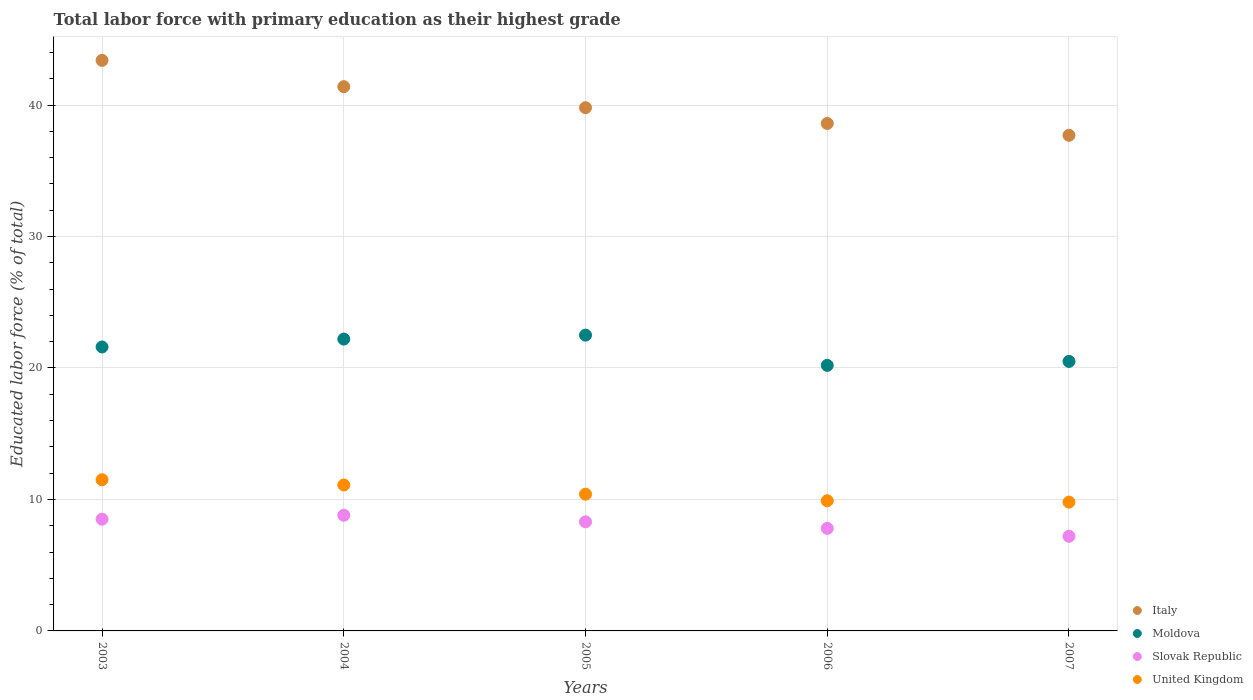How many different coloured dotlines are there?
Give a very brief answer. 4. What is the percentage of total labor force with primary education in Slovak Republic in 2004?
Make the answer very short. 8.8. Across all years, what is the maximum percentage of total labor force with primary education in United Kingdom?
Keep it short and to the point. 11.5. Across all years, what is the minimum percentage of total labor force with primary education in Slovak Republic?
Provide a short and direct response. 7.2. In which year was the percentage of total labor force with primary education in Slovak Republic maximum?
Your answer should be very brief. 2004. In which year was the percentage of total labor force with primary education in Slovak Republic minimum?
Make the answer very short. 2007. What is the total percentage of total labor force with primary education in United Kingdom in the graph?
Make the answer very short. 52.7. What is the difference between the percentage of total labor force with primary education in United Kingdom in 2006 and that in 2007?
Give a very brief answer. 0.1. What is the difference between the percentage of total labor force with primary education in Italy in 2006 and the percentage of total labor force with primary education in Slovak Republic in 2004?
Offer a terse response. 29.8. What is the average percentage of total labor force with primary education in Moldova per year?
Your response must be concise. 21.4. In the year 2005, what is the difference between the percentage of total labor force with primary education in Moldova and percentage of total labor force with primary education in United Kingdom?
Keep it short and to the point. 12.1. In how many years, is the percentage of total labor force with primary education in Italy greater than 2 %?
Provide a succinct answer. 5. What is the ratio of the percentage of total labor force with primary education in Moldova in 2004 to that in 2005?
Give a very brief answer. 0.99. Is the percentage of total labor force with primary education in Slovak Republic in 2003 less than that in 2006?
Your response must be concise. No. What is the difference between the highest and the second highest percentage of total labor force with primary education in United Kingdom?
Your response must be concise. 0.4. What is the difference between the highest and the lowest percentage of total labor force with primary education in Italy?
Provide a succinct answer. 5.7. Is it the case that in every year, the sum of the percentage of total labor force with primary education in Moldova and percentage of total labor force with primary education in United Kingdom  is greater than the sum of percentage of total labor force with primary education in Slovak Republic and percentage of total labor force with primary education in Italy?
Your response must be concise. Yes. Is it the case that in every year, the sum of the percentage of total labor force with primary education in Moldova and percentage of total labor force with primary education in Slovak Republic  is greater than the percentage of total labor force with primary education in Italy?
Keep it short and to the point. No. Does the percentage of total labor force with primary education in Moldova monotonically increase over the years?
Give a very brief answer. No. Is the percentage of total labor force with primary education in Slovak Republic strictly less than the percentage of total labor force with primary education in Italy over the years?
Provide a succinct answer. Yes. How many dotlines are there?
Your response must be concise. 4. What is the difference between two consecutive major ticks on the Y-axis?
Offer a very short reply. 10. Are the values on the major ticks of Y-axis written in scientific E-notation?
Your response must be concise. No. Does the graph contain any zero values?
Give a very brief answer. No. Does the graph contain grids?
Provide a short and direct response. Yes. How are the legend labels stacked?
Keep it short and to the point. Vertical. What is the title of the graph?
Your answer should be very brief. Total labor force with primary education as their highest grade. What is the label or title of the X-axis?
Your response must be concise. Years. What is the label or title of the Y-axis?
Keep it short and to the point. Educated labor force (% of total). What is the Educated labor force (% of total) in Italy in 2003?
Keep it short and to the point. 43.4. What is the Educated labor force (% of total) in Moldova in 2003?
Your answer should be very brief. 21.6. What is the Educated labor force (% of total) in Slovak Republic in 2003?
Your answer should be very brief. 8.5. What is the Educated labor force (% of total) in Italy in 2004?
Your response must be concise. 41.4. What is the Educated labor force (% of total) of Moldova in 2004?
Offer a very short reply. 22.2. What is the Educated labor force (% of total) in Slovak Republic in 2004?
Ensure brevity in your answer.  8.8. What is the Educated labor force (% of total) of United Kingdom in 2004?
Provide a succinct answer. 11.1. What is the Educated labor force (% of total) of Italy in 2005?
Provide a short and direct response. 39.8. What is the Educated labor force (% of total) of Moldova in 2005?
Offer a terse response. 22.5. What is the Educated labor force (% of total) in Slovak Republic in 2005?
Ensure brevity in your answer.  8.3. What is the Educated labor force (% of total) of United Kingdom in 2005?
Your answer should be very brief. 10.4. What is the Educated labor force (% of total) of Italy in 2006?
Your answer should be very brief. 38.6. What is the Educated labor force (% of total) of Moldova in 2006?
Your answer should be very brief. 20.2. What is the Educated labor force (% of total) of Slovak Republic in 2006?
Give a very brief answer. 7.8. What is the Educated labor force (% of total) of United Kingdom in 2006?
Make the answer very short. 9.9. What is the Educated labor force (% of total) in Italy in 2007?
Keep it short and to the point. 37.7. What is the Educated labor force (% of total) in Moldova in 2007?
Provide a succinct answer. 20.5. What is the Educated labor force (% of total) of Slovak Republic in 2007?
Your answer should be compact. 7.2. What is the Educated labor force (% of total) in United Kingdom in 2007?
Provide a short and direct response. 9.8. Across all years, what is the maximum Educated labor force (% of total) in Italy?
Provide a short and direct response. 43.4. Across all years, what is the maximum Educated labor force (% of total) in Moldova?
Ensure brevity in your answer.  22.5. Across all years, what is the maximum Educated labor force (% of total) of Slovak Republic?
Give a very brief answer. 8.8. Across all years, what is the maximum Educated labor force (% of total) in United Kingdom?
Ensure brevity in your answer.  11.5. Across all years, what is the minimum Educated labor force (% of total) of Italy?
Your answer should be compact. 37.7. Across all years, what is the minimum Educated labor force (% of total) of Moldova?
Provide a succinct answer. 20.2. Across all years, what is the minimum Educated labor force (% of total) of Slovak Republic?
Ensure brevity in your answer.  7.2. Across all years, what is the minimum Educated labor force (% of total) of United Kingdom?
Make the answer very short. 9.8. What is the total Educated labor force (% of total) in Italy in the graph?
Offer a terse response. 200.9. What is the total Educated labor force (% of total) of Moldova in the graph?
Keep it short and to the point. 107. What is the total Educated labor force (% of total) in Slovak Republic in the graph?
Provide a succinct answer. 40.6. What is the total Educated labor force (% of total) of United Kingdom in the graph?
Your answer should be compact. 52.7. What is the difference between the Educated labor force (% of total) of Italy in 2003 and that in 2004?
Give a very brief answer. 2. What is the difference between the Educated labor force (% of total) in Moldova in 2003 and that in 2004?
Make the answer very short. -0.6. What is the difference between the Educated labor force (% of total) in Slovak Republic in 2003 and that in 2004?
Your answer should be very brief. -0.3. What is the difference between the Educated labor force (% of total) of Italy in 2003 and that in 2005?
Offer a terse response. 3.6. What is the difference between the Educated labor force (% of total) of Moldova in 2003 and that in 2005?
Keep it short and to the point. -0.9. What is the difference between the Educated labor force (% of total) in Slovak Republic in 2003 and that in 2006?
Provide a short and direct response. 0.7. What is the difference between the Educated labor force (% of total) in United Kingdom in 2003 and that in 2006?
Offer a very short reply. 1.6. What is the difference between the Educated labor force (% of total) in Italy in 2003 and that in 2007?
Ensure brevity in your answer.  5.7. What is the difference between the Educated labor force (% of total) of Moldova in 2003 and that in 2007?
Offer a terse response. 1.1. What is the difference between the Educated labor force (% of total) in Slovak Republic in 2003 and that in 2007?
Make the answer very short. 1.3. What is the difference between the Educated labor force (% of total) of United Kingdom in 2003 and that in 2007?
Offer a terse response. 1.7. What is the difference between the Educated labor force (% of total) of Slovak Republic in 2004 and that in 2005?
Keep it short and to the point. 0.5. What is the difference between the Educated labor force (% of total) in Italy in 2004 and that in 2006?
Your answer should be very brief. 2.8. What is the difference between the Educated labor force (% of total) in Moldova in 2004 and that in 2006?
Give a very brief answer. 2. What is the difference between the Educated labor force (% of total) of United Kingdom in 2004 and that in 2006?
Give a very brief answer. 1.2. What is the difference between the Educated labor force (% of total) of Italy in 2004 and that in 2007?
Give a very brief answer. 3.7. What is the difference between the Educated labor force (% of total) of Moldova in 2004 and that in 2007?
Your answer should be compact. 1.7. What is the difference between the Educated labor force (% of total) of Italy in 2005 and that in 2006?
Provide a short and direct response. 1.2. What is the difference between the Educated labor force (% of total) in Moldova in 2005 and that in 2006?
Make the answer very short. 2.3. What is the difference between the Educated labor force (% of total) of Slovak Republic in 2005 and that in 2006?
Provide a short and direct response. 0.5. What is the difference between the Educated labor force (% of total) of Italy in 2005 and that in 2007?
Give a very brief answer. 2.1. What is the difference between the Educated labor force (% of total) of Italy in 2006 and that in 2007?
Offer a very short reply. 0.9. What is the difference between the Educated labor force (% of total) in Moldova in 2006 and that in 2007?
Offer a terse response. -0.3. What is the difference between the Educated labor force (% of total) in Slovak Republic in 2006 and that in 2007?
Keep it short and to the point. 0.6. What is the difference between the Educated labor force (% of total) in Italy in 2003 and the Educated labor force (% of total) in Moldova in 2004?
Provide a short and direct response. 21.2. What is the difference between the Educated labor force (% of total) in Italy in 2003 and the Educated labor force (% of total) in Slovak Republic in 2004?
Offer a terse response. 34.6. What is the difference between the Educated labor force (% of total) in Italy in 2003 and the Educated labor force (% of total) in United Kingdom in 2004?
Provide a succinct answer. 32.3. What is the difference between the Educated labor force (% of total) in Slovak Republic in 2003 and the Educated labor force (% of total) in United Kingdom in 2004?
Offer a very short reply. -2.6. What is the difference between the Educated labor force (% of total) of Italy in 2003 and the Educated labor force (% of total) of Moldova in 2005?
Make the answer very short. 20.9. What is the difference between the Educated labor force (% of total) of Italy in 2003 and the Educated labor force (% of total) of Slovak Republic in 2005?
Give a very brief answer. 35.1. What is the difference between the Educated labor force (% of total) of Slovak Republic in 2003 and the Educated labor force (% of total) of United Kingdom in 2005?
Your answer should be very brief. -1.9. What is the difference between the Educated labor force (% of total) of Italy in 2003 and the Educated labor force (% of total) of Moldova in 2006?
Offer a terse response. 23.2. What is the difference between the Educated labor force (% of total) of Italy in 2003 and the Educated labor force (% of total) of Slovak Republic in 2006?
Give a very brief answer. 35.6. What is the difference between the Educated labor force (% of total) in Italy in 2003 and the Educated labor force (% of total) in United Kingdom in 2006?
Offer a very short reply. 33.5. What is the difference between the Educated labor force (% of total) in Moldova in 2003 and the Educated labor force (% of total) in United Kingdom in 2006?
Provide a short and direct response. 11.7. What is the difference between the Educated labor force (% of total) in Slovak Republic in 2003 and the Educated labor force (% of total) in United Kingdom in 2006?
Provide a short and direct response. -1.4. What is the difference between the Educated labor force (% of total) in Italy in 2003 and the Educated labor force (% of total) in Moldova in 2007?
Provide a short and direct response. 22.9. What is the difference between the Educated labor force (% of total) of Italy in 2003 and the Educated labor force (% of total) of Slovak Republic in 2007?
Give a very brief answer. 36.2. What is the difference between the Educated labor force (% of total) in Italy in 2003 and the Educated labor force (% of total) in United Kingdom in 2007?
Ensure brevity in your answer.  33.6. What is the difference between the Educated labor force (% of total) of Italy in 2004 and the Educated labor force (% of total) of Moldova in 2005?
Your response must be concise. 18.9. What is the difference between the Educated labor force (% of total) in Italy in 2004 and the Educated labor force (% of total) in Slovak Republic in 2005?
Provide a succinct answer. 33.1. What is the difference between the Educated labor force (% of total) in Moldova in 2004 and the Educated labor force (% of total) in United Kingdom in 2005?
Keep it short and to the point. 11.8. What is the difference between the Educated labor force (% of total) in Italy in 2004 and the Educated labor force (% of total) in Moldova in 2006?
Ensure brevity in your answer.  21.2. What is the difference between the Educated labor force (% of total) of Italy in 2004 and the Educated labor force (% of total) of Slovak Republic in 2006?
Give a very brief answer. 33.6. What is the difference between the Educated labor force (% of total) in Italy in 2004 and the Educated labor force (% of total) in United Kingdom in 2006?
Offer a very short reply. 31.5. What is the difference between the Educated labor force (% of total) of Moldova in 2004 and the Educated labor force (% of total) of United Kingdom in 2006?
Provide a short and direct response. 12.3. What is the difference between the Educated labor force (% of total) of Slovak Republic in 2004 and the Educated labor force (% of total) of United Kingdom in 2006?
Offer a terse response. -1.1. What is the difference between the Educated labor force (% of total) of Italy in 2004 and the Educated labor force (% of total) of Moldova in 2007?
Your answer should be very brief. 20.9. What is the difference between the Educated labor force (% of total) in Italy in 2004 and the Educated labor force (% of total) in Slovak Republic in 2007?
Give a very brief answer. 34.2. What is the difference between the Educated labor force (% of total) in Italy in 2004 and the Educated labor force (% of total) in United Kingdom in 2007?
Ensure brevity in your answer.  31.6. What is the difference between the Educated labor force (% of total) in Moldova in 2004 and the Educated labor force (% of total) in United Kingdom in 2007?
Make the answer very short. 12.4. What is the difference between the Educated labor force (% of total) of Slovak Republic in 2004 and the Educated labor force (% of total) of United Kingdom in 2007?
Offer a very short reply. -1. What is the difference between the Educated labor force (% of total) in Italy in 2005 and the Educated labor force (% of total) in Moldova in 2006?
Offer a very short reply. 19.6. What is the difference between the Educated labor force (% of total) of Italy in 2005 and the Educated labor force (% of total) of Slovak Republic in 2006?
Give a very brief answer. 32. What is the difference between the Educated labor force (% of total) in Italy in 2005 and the Educated labor force (% of total) in United Kingdom in 2006?
Keep it short and to the point. 29.9. What is the difference between the Educated labor force (% of total) in Moldova in 2005 and the Educated labor force (% of total) in Slovak Republic in 2006?
Ensure brevity in your answer.  14.7. What is the difference between the Educated labor force (% of total) in Moldova in 2005 and the Educated labor force (% of total) in United Kingdom in 2006?
Offer a very short reply. 12.6. What is the difference between the Educated labor force (% of total) of Slovak Republic in 2005 and the Educated labor force (% of total) of United Kingdom in 2006?
Your response must be concise. -1.6. What is the difference between the Educated labor force (% of total) in Italy in 2005 and the Educated labor force (% of total) in Moldova in 2007?
Provide a succinct answer. 19.3. What is the difference between the Educated labor force (% of total) in Italy in 2005 and the Educated labor force (% of total) in Slovak Republic in 2007?
Offer a very short reply. 32.6. What is the difference between the Educated labor force (% of total) of Slovak Republic in 2005 and the Educated labor force (% of total) of United Kingdom in 2007?
Give a very brief answer. -1.5. What is the difference between the Educated labor force (% of total) in Italy in 2006 and the Educated labor force (% of total) in Moldova in 2007?
Provide a succinct answer. 18.1. What is the difference between the Educated labor force (% of total) of Italy in 2006 and the Educated labor force (% of total) of Slovak Republic in 2007?
Give a very brief answer. 31.4. What is the difference between the Educated labor force (% of total) of Italy in 2006 and the Educated labor force (% of total) of United Kingdom in 2007?
Give a very brief answer. 28.8. What is the difference between the Educated labor force (% of total) in Moldova in 2006 and the Educated labor force (% of total) in Slovak Republic in 2007?
Make the answer very short. 13. What is the difference between the Educated labor force (% of total) in Moldova in 2006 and the Educated labor force (% of total) in United Kingdom in 2007?
Offer a terse response. 10.4. What is the difference between the Educated labor force (% of total) of Slovak Republic in 2006 and the Educated labor force (% of total) of United Kingdom in 2007?
Your answer should be compact. -2. What is the average Educated labor force (% of total) in Italy per year?
Your answer should be very brief. 40.18. What is the average Educated labor force (% of total) of Moldova per year?
Offer a terse response. 21.4. What is the average Educated labor force (% of total) in Slovak Republic per year?
Keep it short and to the point. 8.12. What is the average Educated labor force (% of total) of United Kingdom per year?
Provide a short and direct response. 10.54. In the year 2003, what is the difference between the Educated labor force (% of total) of Italy and Educated labor force (% of total) of Moldova?
Your response must be concise. 21.8. In the year 2003, what is the difference between the Educated labor force (% of total) of Italy and Educated labor force (% of total) of Slovak Republic?
Ensure brevity in your answer.  34.9. In the year 2003, what is the difference between the Educated labor force (% of total) in Italy and Educated labor force (% of total) in United Kingdom?
Your answer should be compact. 31.9. In the year 2004, what is the difference between the Educated labor force (% of total) in Italy and Educated labor force (% of total) in Moldova?
Provide a short and direct response. 19.2. In the year 2004, what is the difference between the Educated labor force (% of total) in Italy and Educated labor force (% of total) in Slovak Republic?
Provide a short and direct response. 32.6. In the year 2004, what is the difference between the Educated labor force (% of total) in Italy and Educated labor force (% of total) in United Kingdom?
Your answer should be compact. 30.3. In the year 2004, what is the difference between the Educated labor force (% of total) in Moldova and Educated labor force (% of total) in Slovak Republic?
Keep it short and to the point. 13.4. In the year 2004, what is the difference between the Educated labor force (% of total) of Slovak Republic and Educated labor force (% of total) of United Kingdom?
Give a very brief answer. -2.3. In the year 2005, what is the difference between the Educated labor force (% of total) in Italy and Educated labor force (% of total) in Moldova?
Give a very brief answer. 17.3. In the year 2005, what is the difference between the Educated labor force (% of total) in Italy and Educated labor force (% of total) in Slovak Republic?
Offer a terse response. 31.5. In the year 2005, what is the difference between the Educated labor force (% of total) in Italy and Educated labor force (% of total) in United Kingdom?
Your answer should be very brief. 29.4. In the year 2006, what is the difference between the Educated labor force (% of total) of Italy and Educated labor force (% of total) of Slovak Republic?
Provide a succinct answer. 30.8. In the year 2006, what is the difference between the Educated labor force (% of total) of Italy and Educated labor force (% of total) of United Kingdom?
Offer a terse response. 28.7. In the year 2006, what is the difference between the Educated labor force (% of total) of Moldova and Educated labor force (% of total) of United Kingdom?
Offer a very short reply. 10.3. In the year 2006, what is the difference between the Educated labor force (% of total) in Slovak Republic and Educated labor force (% of total) in United Kingdom?
Provide a succinct answer. -2.1. In the year 2007, what is the difference between the Educated labor force (% of total) of Italy and Educated labor force (% of total) of Moldova?
Ensure brevity in your answer.  17.2. In the year 2007, what is the difference between the Educated labor force (% of total) in Italy and Educated labor force (% of total) in Slovak Republic?
Offer a terse response. 30.5. In the year 2007, what is the difference between the Educated labor force (% of total) of Italy and Educated labor force (% of total) of United Kingdom?
Provide a short and direct response. 27.9. What is the ratio of the Educated labor force (% of total) in Italy in 2003 to that in 2004?
Offer a terse response. 1.05. What is the ratio of the Educated labor force (% of total) in Slovak Republic in 2003 to that in 2004?
Provide a short and direct response. 0.97. What is the ratio of the Educated labor force (% of total) in United Kingdom in 2003 to that in 2004?
Give a very brief answer. 1.04. What is the ratio of the Educated labor force (% of total) of Italy in 2003 to that in 2005?
Your response must be concise. 1.09. What is the ratio of the Educated labor force (% of total) in Slovak Republic in 2003 to that in 2005?
Offer a terse response. 1.02. What is the ratio of the Educated labor force (% of total) of United Kingdom in 2003 to that in 2005?
Provide a short and direct response. 1.11. What is the ratio of the Educated labor force (% of total) in Italy in 2003 to that in 2006?
Provide a succinct answer. 1.12. What is the ratio of the Educated labor force (% of total) in Moldova in 2003 to that in 2006?
Give a very brief answer. 1.07. What is the ratio of the Educated labor force (% of total) of Slovak Republic in 2003 to that in 2006?
Provide a short and direct response. 1.09. What is the ratio of the Educated labor force (% of total) in United Kingdom in 2003 to that in 2006?
Ensure brevity in your answer.  1.16. What is the ratio of the Educated labor force (% of total) of Italy in 2003 to that in 2007?
Your answer should be compact. 1.15. What is the ratio of the Educated labor force (% of total) in Moldova in 2003 to that in 2007?
Provide a short and direct response. 1.05. What is the ratio of the Educated labor force (% of total) of Slovak Republic in 2003 to that in 2007?
Give a very brief answer. 1.18. What is the ratio of the Educated labor force (% of total) of United Kingdom in 2003 to that in 2007?
Offer a terse response. 1.17. What is the ratio of the Educated labor force (% of total) of Italy in 2004 to that in 2005?
Provide a succinct answer. 1.04. What is the ratio of the Educated labor force (% of total) in Moldova in 2004 to that in 2005?
Ensure brevity in your answer.  0.99. What is the ratio of the Educated labor force (% of total) of Slovak Republic in 2004 to that in 2005?
Give a very brief answer. 1.06. What is the ratio of the Educated labor force (% of total) in United Kingdom in 2004 to that in 2005?
Make the answer very short. 1.07. What is the ratio of the Educated labor force (% of total) in Italy in 2004 to that in 2006?
Give a very brief answer. 1.07. What is the ratio of the Educated labor force (% of total) of Moldova in 2004 to that in 2006?
Make the answer very short. 1.1. What is the ratio of the Educated labor force (% of total) of Slovak Republic in 2004 to that in 2006?
Provide a short and direct response. 1.13. What is the ratio of the Educated labor force (% of total) in United Kingdom in 2004 to that in 2006?
Your answer should be compact. 1.12. What is the ratio of the Educated labor force (% of total) of Italy in 2004 to that in 2007?
Offer a terse response. 1.1. What is the ratio of the Educated labor force (% of total) of Moldova in 2004 to that in 2007?
Provide a succinct answer. 1.08. What is the ratio of the Educated labor force (% of total) of Slovak Republic in 2004 to that in 2007?
Provide a succinct answer. 1.22. What is the ratio of the Educated labor force (% of total) of United Kingdom in 2004 to that in 2007?
Provide a short and direct response. 1.13. What is the ratio of the Educated labor force (% of total) of Italy in 2005 to that in 2006?
Your answer should be compact. 1.03. What is the ratio of the Educated labor force (% of total) in Moldova in 2005 to that in 2006?
Offer a terse response. 1.11. What is the ratio of the Educated labor force (% of total) in Slovak Republic in 2005 to that in 2006?
Provide a succinct answer. 1.06. What is the ratio of the Educated labor force (% of total) of United Kingdom in 2005 to that in 2006?
Offer a terse response. 1.05. What is the ratio of the Educated labor force (% of total) of Italy in 2005 to that in 2007?
Your answer should be very brief. 1.06. What is the ratio of the Educated labor force (% of total) in Moldova in 2005 to that in 2007?
Provide a succinct answer. 1.1. What is the ratio of the Educated labor force (% of total) of Slovak Republic in 2005 to that in 2007?
Offer a very short reply. 1.15. What is the ratio of the Educated labor force (% of total) in United Kingdom in 2005 to that in 2007?
Make the answer very short. 1.06. What is the ratio of the Educated labor force (% of total) of Italy in 2006 to that in 2007?
Offer a terse response. 1.02. What is the ratio of the Educated labor force (% of total) in Moldova in 2006 to that in 2007?
Make the answer very short. 0.99. What is the ratio of the Educated labor force (% of total) in Slovak Republic in 2006 to that in 2007?
Make the answer very short. 1.08. What is the ratio of the Educated labor force (% of total) of United Kingdom in 2006 to that in 2007?
Your response must be concise. 1.01. What is the difference between the highest and the second highest Educated labor force (% of total) of Italy?
Offer a very short reply. 2. What is the difference between the highest and the second highest Educated labor force (% of total) of Moldova?
Your answer should be very brief. 0.3. What is the difference between the highest and the second highest Educated labor force (% of total) of Slovak Republic?
Your answer should be very brief. 0.3. What is the difference between the highest and the lowest Educated labor force (% of total) of Italy?
Offer a very short reply. 5.7. What is the difference between the highest and the lowest Educated labor force (% of total) in Moldova?
Provide a short and direct response. 2.3. What is the difference between the highest and the lowest Educated labor force (% of total) in Slovak Republic?
Your response must be concise. 1.6. 